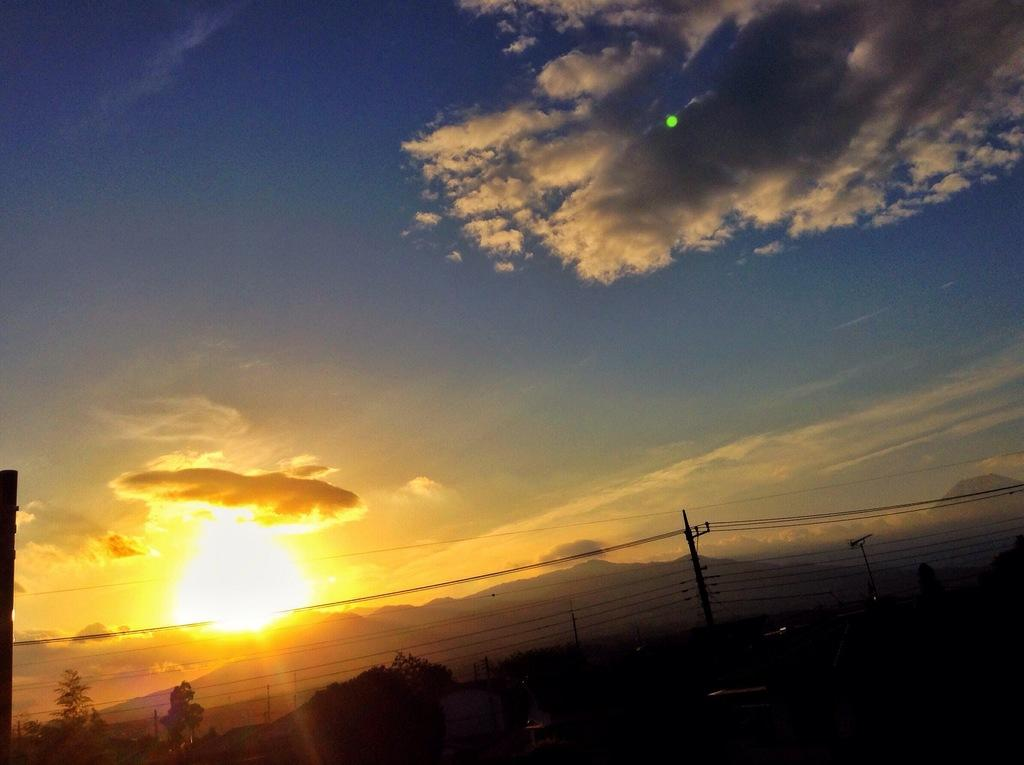What structures are present in the image? There are poles and wires in the image. What type of natural elements can be seen in the image? There are trees and a mountain in the image. What is visible in the background of the image? The sky is visible in the background of the image. What can be observed in the sky? There are clouds and the sun visible in the sky. What type of paste is being used to hold the poles together in the image? There is no paste present in the image; the poles are likely held together by other means, such as bolts or cement. 